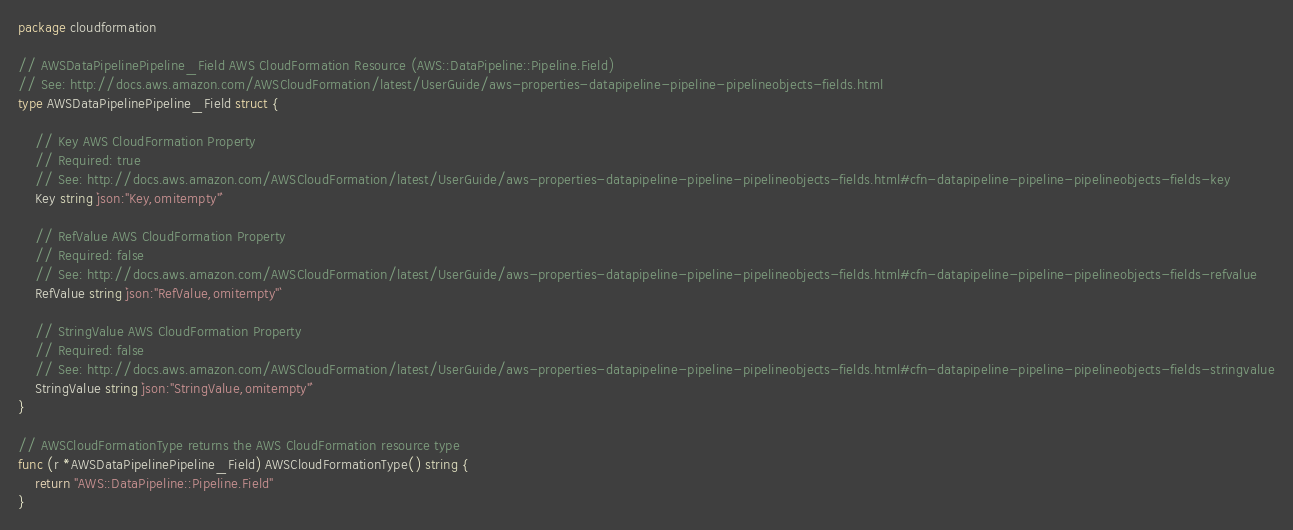Convert code to text. <code><loc_0><loc_0><loc_500><loc_500><_Go_>package cloudformation

// AWSDataPipelinePipeline_Field AWS CloudFormation Resource (AWS::DataPipeline::Pipeline.Field)
// See: http://docs.aws.amazon.com/AWSCloudFormation/latest/UserGuide/aws-properties-datapipeline-pipeline-pipelineobjects-fields.html
type AWSDataPipelinePipeline_Field struct {

	// Key AWS CloudFormation Property
	// Required: true
	// See: http://docs.aws.amazon.com/AWSCloudFormation/latest/UserGuide/aws-properties-datapipeline-pipeline-pipelineobjects-fields.html#cfn-datapipeline-pipeline-pipelineobjects-fields-key
	Key string `json:"Key,omitempty"`

	// RefValue AWS CloudFormation Property
	// Required: false
	// See: http://docs.aws.amazon.com/AWSCloudFormation/latest/UserGuide/aws-properties-datapipeline-pipeline-pipelineobjects-fields.html#cfn-datapipeline-pipeline-pipelineobjects-fields-refvalue
	RefValue string `json:"RefValue,omitempty"`

	// StringValue AWS CloudFormation Property
	// Required: false
	// See: http://docs.aws.amazon.com/AWSCloudFormation/latest/UserGuide/aws-properties-datapipeline-pipeline-pipelineobjects-fields.html#cfn-datapipeline-pipeline-pipelineobjects-fields-stringvalue
	StringValue string `json:"StringValue,omitempty"`
}

// AWSCloudFormationType returns the AWS CloudFormation resource type
func (r *AWSDataPipelinePipeline_Field) AWSCloudFormationType() string {
	return "AWS::DataPipeline::Pipeline.Field"
}
</code> 